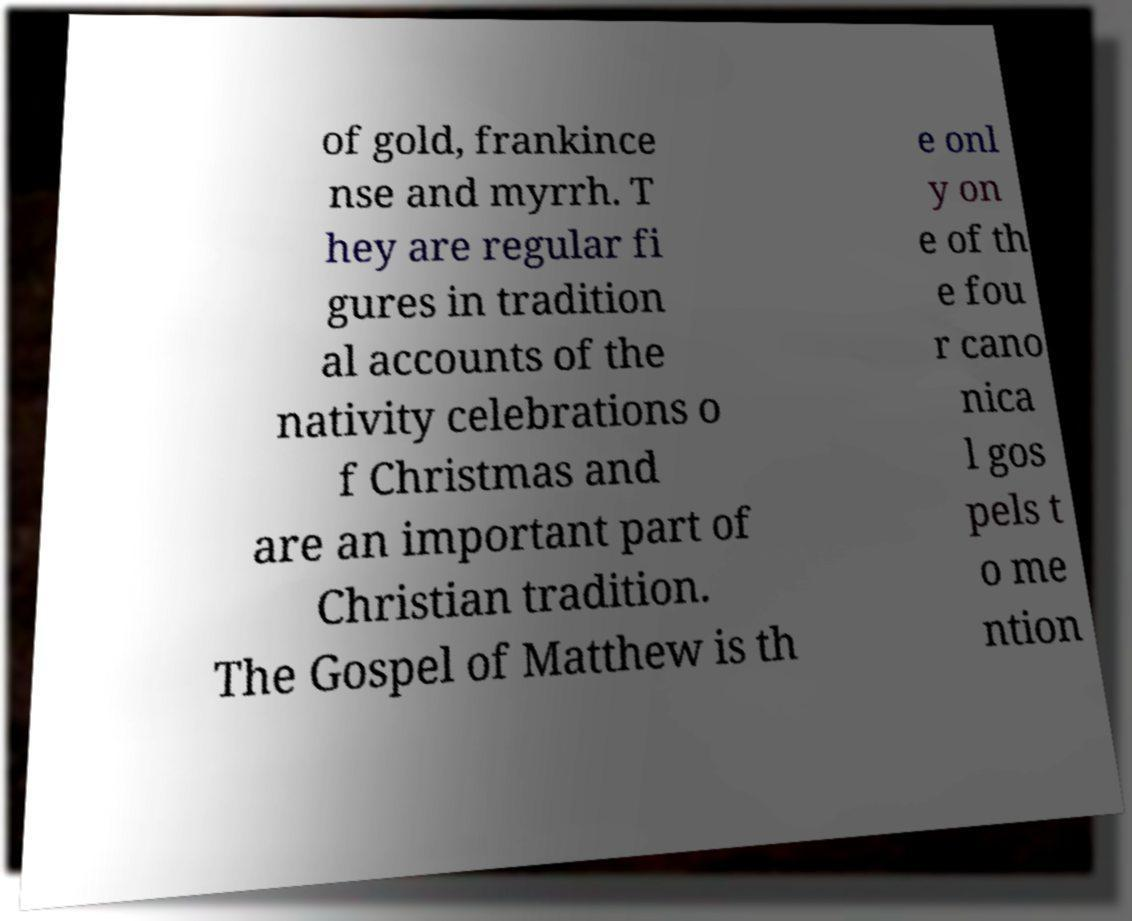Can you read and provide the text displayed in the image?This photo seems to have some interesting text. Can you extract and type it out for me? of gold, frankince nse and myrrh. T hey are regular fi gures in tradition al accounts of the nativity celebrations o f Christmas and are an important part of Christian tradition. The Gospel of Matthew is th e onl y on e of th e fou r cano nica l gos pels t o me ntion 